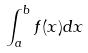Convert formula to latex. <formula><loc_0><loc_0><loc_500><loc_500>\int _ { a } ^ { b } f ( x ) d x</formula> 